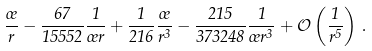<formula> <loc_0><loc_0><loc_500><loc_500>\frac { \sigma } { r } - \frac { 6 7 } { 1 5 5 5 2 } \frac { 1 } { \sigma r } + \frac { 1 } { 2 1 6 } \frac { \sigma } { r ^ { 3 } } - \frac { 2 1 5 } { 3 7 3 2 4 8 } \frac { 1 } { \sigma r ^ { 3 } } + \mathcal { O } \left ( \frac { 1 } { r ^ { 5 } } \right ) \, .</formula> 